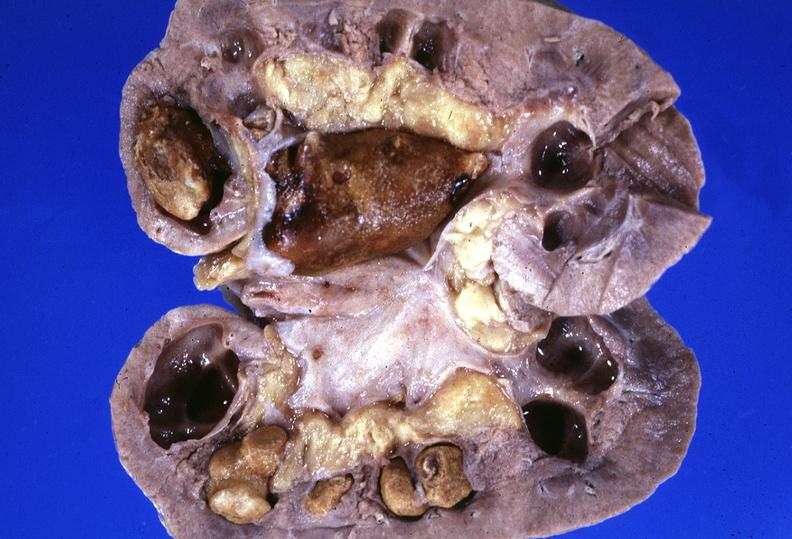does this image show kidney, staghorn calculi?
Answer the question using a single word or phrase. Yes 